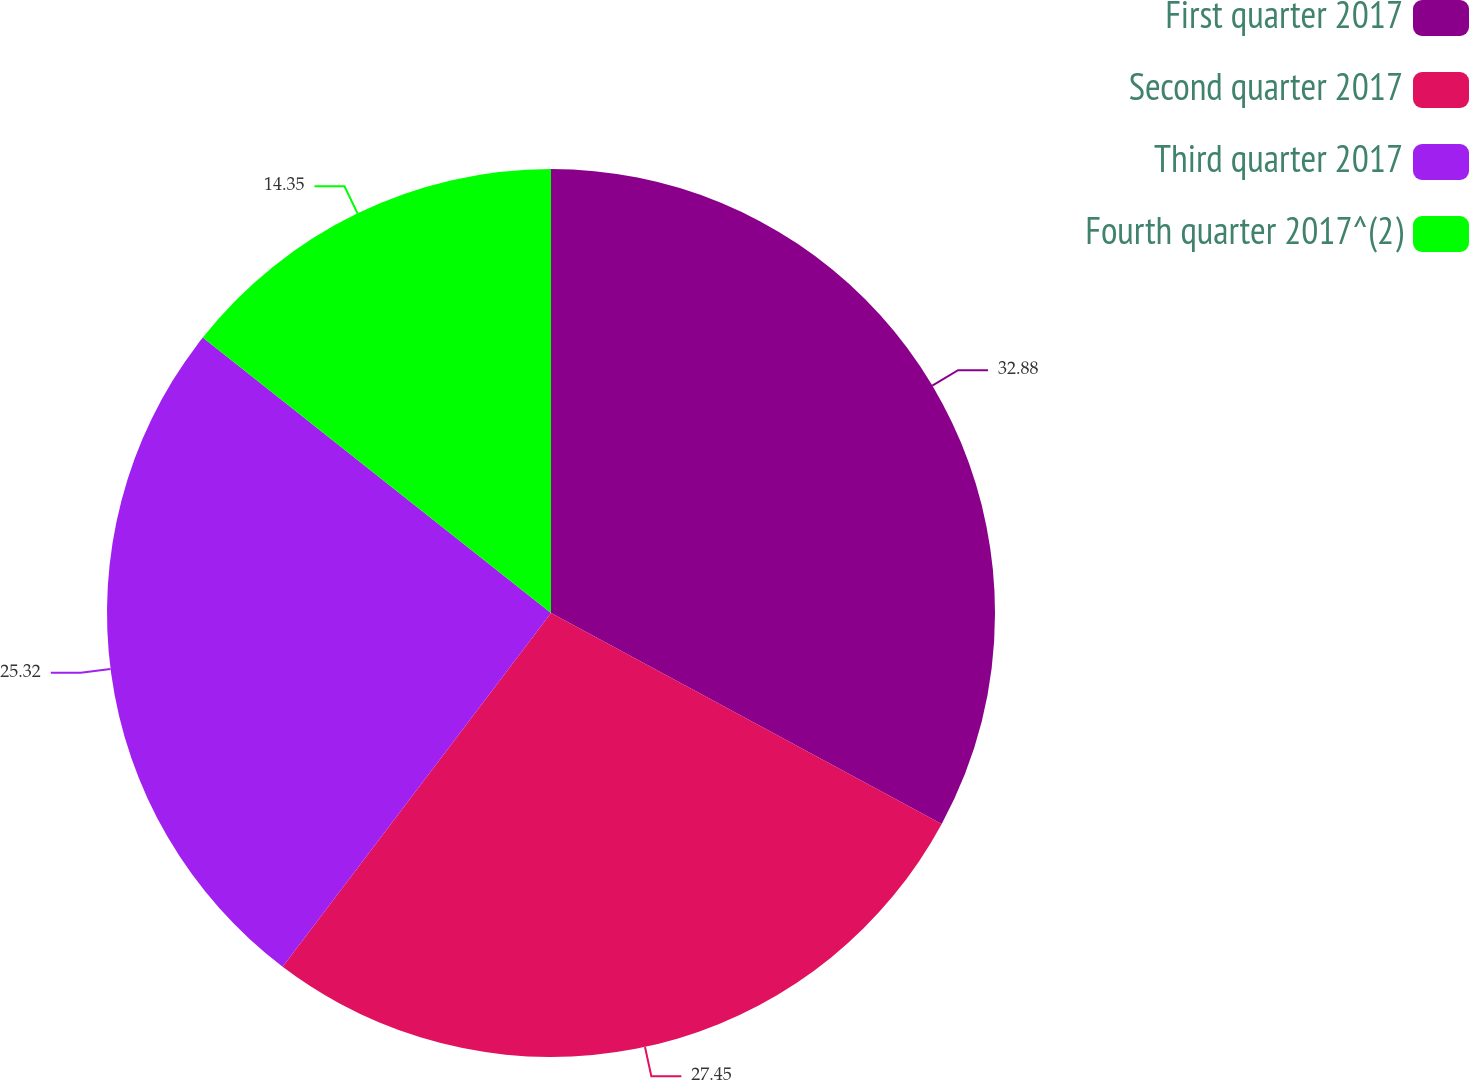<chart> <loc_0><loc_0><loc_500><loc_500><pie_chart><fcel>First quarter 2017<fcel>Second quarter 2017<fcel>Third quarter 2017<fcel>Fourth quarter 2017^(2)<nl><fcel>32.88%<fcel>27.45%<fcel>25.32%<fcel>14.35%<nl></chart> 